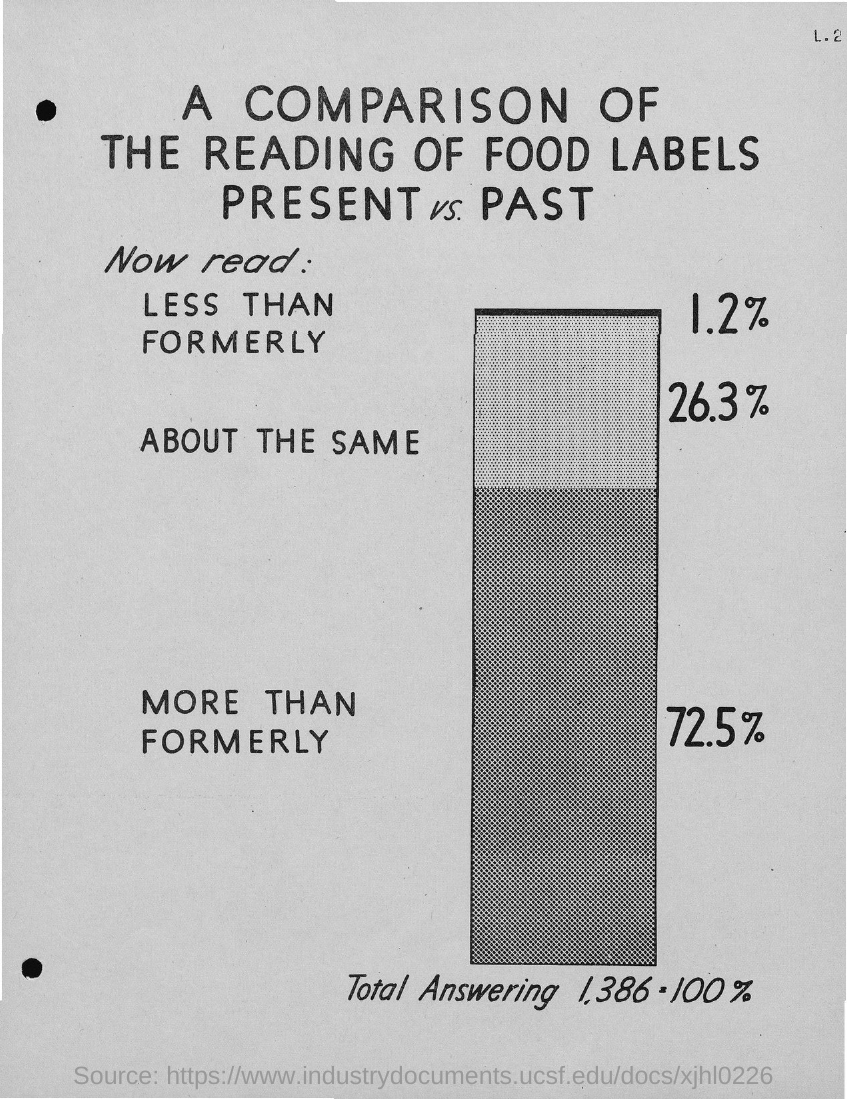What comparison is given in this document?
Your answer should be very brief. A comparison of the reading of food labels present vs. past. 